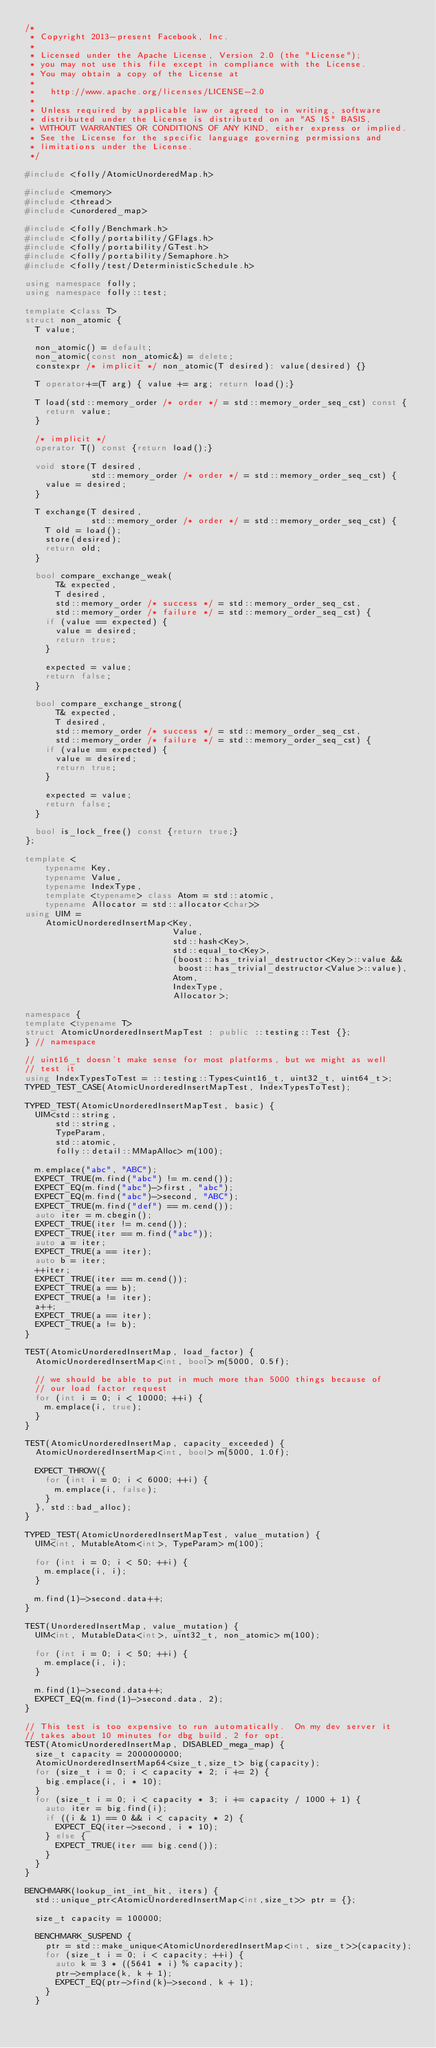Convert code to text. <code><loc_0><loc_0><loc_500><loc_500><_C++_>/*
 * Copyright 2013-present Facebook, Inc.
 *
 * Licensed under the Apache License, Version 2.0 (the "License");
 * you may not use this file except in compliance with the License.
 * You may obtain a copy of the License at
 *
 *   http://www.apache.org/licenses/LICENSE-2.0
 *
 * Unless required by applicable law or agreed to in writing, software
 * distributed under the License is distributed on an "AS IS" BASIS,
 * WITHOUT WARRANTIES OR CONDITIONS OF ANY KIND, either express or implied.
 * See the License for the specific language governing permissions and
 * limitations under the License.
 */

#include <folly/AtomicUnorderedMap.h>

#include <memory>
#include <thread>
#include <unordered_map>

#include <folly/Benchmark.h>
#include <folly/portability/GFlags.h>
#include <folly/portability/GTest.h>
#include <folly/portability/Semaphore.h>
#include <folly/test/DeterministicSchedule.h>

using namespace folly;
using namespace folly::test;

template <class T>
struct non_atomic {
  T value;

  non_atomic() = default;
  non_atomic(const non_atomic&) = delete;
  constexpr /* implicit */ non_atomic(T desired): value(desired) {}

  T operator+=(T arg) { value += arg; return load();}

  T load(std::memory_order /* order */ = std::memory_order_seq_cst) const {
    return value;
  }

  /* implicit */
  operator T() const {return load();}

  void store(T desired,
             std::memory_order /* order */ = std::memory_order_seq_cst) {
    value = desired;
  }

  T exchange(T desired,
             std::memory_order /* order */ = std::memory_order_seq_cst) {
    T old = load();
    store(desired);
    return old;
  }

  bool compare_exchange_weak(
      T& expected,
      T desired,
      std::memory_order /* success */ = std::memory_order_seq_cst,
      std::memory_order /* failure */ = std::memory_order_seq_cst) {
    if (value == expected) {
      value = desired;
      return true;
    }

    expected = value;
    return false;
  }

  bool compare_exchange_strong(
      T& expected,
      T desired,
      std::memory_order /* success */ = std::memory_order_seq_cst,
      std::memory_order /* failure */ = std::memory_order_seq_cst) {
    if (value == expected) {
      value = desired;
      return true;
    }

    expected = value;
    return false;
  }

  bool is_lock_free() const {return true;}
};

template <
    typename Key,
    typename Value,
    typename IndexType,
    template <typename> class Atom = std::atomic,
    typename Allocator = std::allocator<char>>
using UIM =
    AtomicUnorderedInsertMap<Key,
                             Value,
                             std::hash<Key>,
                             std::equal_to<Key>,
                             (boost::has_trivial_destructor<Key>::value &&
                              boost::has_trivial_destructor<Value>::value),
                             Atom,
                             IndexType,
                             Allocator>;

namespace {
template <typename T>
struct AtomicUnorderedInsertMapTest : public ::testing::Test {};
} // namespace

// uint16_t doesn't make sense for most platforms, but we might as well
// test it
using IndexTypesToTest = ::testing::Types<uint16_t, uint32_t, uint64_t>;
TYPED_TEST_CASE(AtomicUnorderedInsertMapTest, IndexTypesToTest);

TYPED_TEST(AtomicUnorderedInsertMapTest, basic) {
  UIM<std::string,
      std::string,
      TypeParam,
      std::atomic,
      folly::detail::MMapAlloc> m(100);

  m.emplace("abc", "ABC");
  EXPECT_TRUE(m.find("abc") != m.cend());
  EXPECT_EQ(m.find("abc")->first, "abc");
  EXPECT_EQ(m.find("abc")->second, "ABC");
  EXPECT_TRUE(m.find("def") == m.cend());
  auto iter = m.cbegin();
  EXPECT_TRUE(iter != m.cend());
  EXPECT_TRUE(iter == m.find("abc"));
  auto a = iter;
  EXPECT_TRUE(a == iter);
  auto b = iter;
  ++iter;
  EXPECT_TRUE(iter == m.cend());
  EXPECT_TRUE(a == b);
  EXPECT_TRUE(a != iter);
  a++;
  EXPECT_TRUE(a == iter);
  EXPECT_TRUE(a != b);
}

TEST(AtomicUnorderedInsertMap, load_factor) {
  AtomicUnorderedInsertMap<int, bool> m(5000, 0.5f);

  // we should be able to put in much more than 5000 things because of
  // our load factor request
  for (int i = 0; i < 10000; ++i) {
    m.emplace(i, true);
  }
}

TEST(AtomicUnorderedInsertMap, capacity_exceeded) {
  AtomicUnorderedInsertMap<int, bool> m(5000, 1.0f);

  EXPECT_THROW({
    for (int i = 0; i < 6000; ++i) {
      m.emplace(i, false);
    }
  }, std::bad_alloc);
}

TYPED_TEST(AtomicUnorderedInsertMapTest, value_mutation) {
  UIM<int, MutableAtom<int>, TypeParam> m(100);

  for (int i = 0; i < 50; ++i) {
    m.emplace(i, i);
  }

  m.find(1)->second.data++;
}

TEST(UnorderedInsertMap, value_mutation) {
  UIM<int, MutableData<int>, uint32_t, non_atomic> m(100);

  for (int i = 0; i < 50; ++i) {
    m.emplace(i, i);
  }

  m.find(1)->second.data++;
  EXPECT_EQ(m.find(1)->second.data, 2);
}

// This test is too expensive to run automatically.  On my dev server it
// takes about 10 minutes for dbg build, 2 for opt.
TEST(AtomicUnorderedInsertMap, DISABLED_mega_map) {
  size_t capacity = 2000000000;
  AtomicUnorderedInsertMap64<size_t,size_t> big(capacity);
  for (size_t i = 0; i < capacity * 2; i += 2) {
    big.emplace(i, i * 10);
  }
  for (size_t i = 0; i < capacity * 3; i += capacity / 1000 + 1) {
    auto iter = big.find(i);
    if ((i & 1) == 0 && i < capacity * 2) {
      EXPECT_EQ(iter->second, i * 10);
    } else {
      EXPECT_TRUE(iter == big.cend());
    }
  }
}

BENCHMARK(lookup_int_int_hit, iters) {
  std::unique_ptr<AtomicUnorderedInsertMap<int,size_t>> ptr = {};

  size_t capacity = 100000;

  BENCHMARK_SUSPEND {
    ptr = std::make_unique<AtomicUnorderedInsertMap<int, size_t>>(capacity);
    for (size_t i = 0; i < capacity; ++i) {
      auto k = 3 * ((5641 * i) % capacity);
      ptr->emplace(k, k + 1);
      EXPECT_EQ(ptr->find(k)->second, k + 1);
    }
  }
</code> 